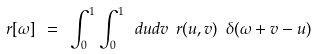<formula> <loc_0><loc_0><loc_500><loc_500>r [ \omega ] \ = \ \int ^ { 1 } _ { 0 } \int ^ { 1 } _ { 0 } \ d u d v \ r ( u , v ) \ \delta ( \omega + v - u )</formula> 